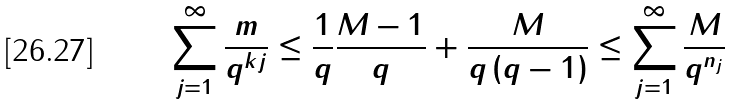Convert formula to latex. <formula><loc_0><loc_0><loc_500><loc_500>\sum _ { j = 1 } ^ { \infty } \frac { m } { q ^ { k j } } \leq \frac { 1 } { q } \frac { M - 1 } { q } + \frac { M } { q \left ( q - 1 \right ) } \leq \sum _ { j = 1 } ^ { \infty } \frac { M } { q ^ { n _ { j } } }</formula> 